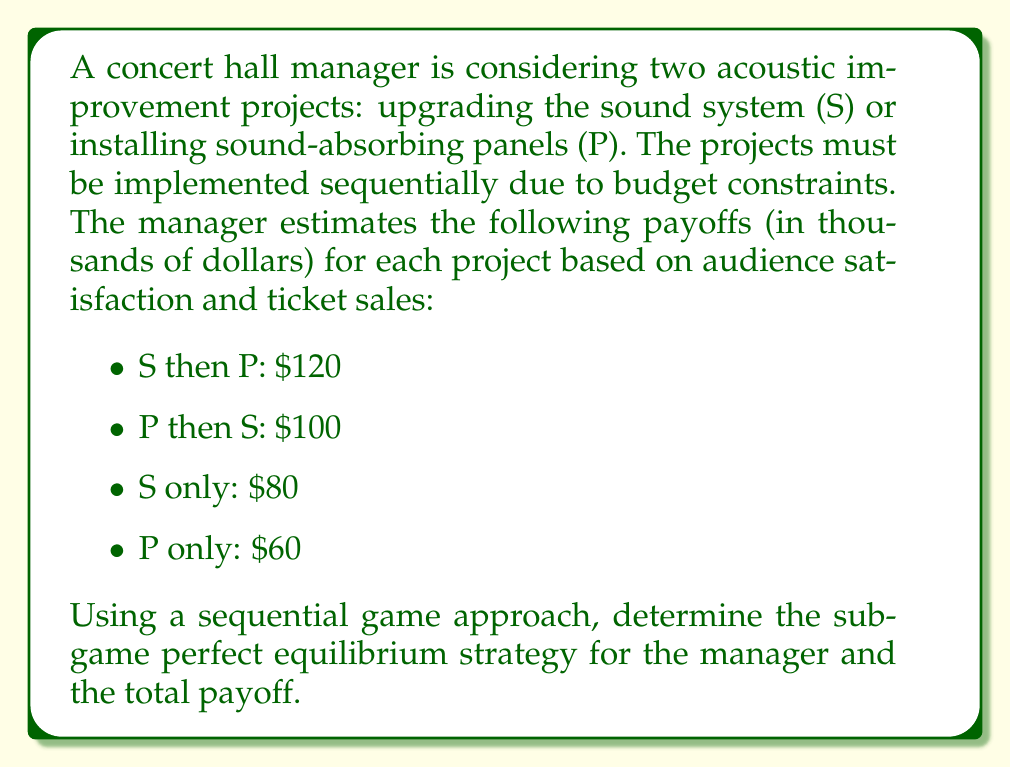Help me with this question. To solve this problem, we'll use backward induction in a sequential game tree:

1. First, let's draw the game tree:

[asy]
unitsize(1cm);

draw((0,0)--(2,1));
draw((0,0)--(2,-1));
draw((2,1)--(4,1.5));
draw((2,1)--(4,0.5));
draw((2,-1)--(4,-0.5));
draw((2,-1)--(4,-1.5));

label("Start", (0,0), W);
label("S", (1,0.5), NW);
label("P", (1,-0.5), SW);
label("P", (3,1.25), N);
label("Stop", (3,0.75), S);
label("S", (3,-0.75), N);
label("Stop", (3,-1.25), S);
label("120", (4,1.5), E);
label("80", (4,0.5), E);
label("100", (4,-0.5), E);
label("60", (4,-1.5), E);
[/asy]

2. We'll use backward induction to solve this game:

   a. If the manager chooses S first:
      - Choosing P next yields $120,000
      - Stopping yields $80,000
      The manager will choose P, resulting in $120,000

   b. If the manager chooses P first:
      - Choosing S next yields $100,000
      - Stopping yields $60,000
      The manager will choose S, resulting in $100,000

3. Now, looking at the first decision:
   - Choosing S first leads to $120,000
   - Choosing P first leads to $100,000

4. Therefore, the manager will choose S first, followed by P.

The subgame perfect equilibrium strategy is (S, P), meaning the manager will first upgrade the sound system and then install sound-absorbing panels.
Answer: The subgame perfect equilibrium strategy is (S, P) with a total payoff of $120,000. 